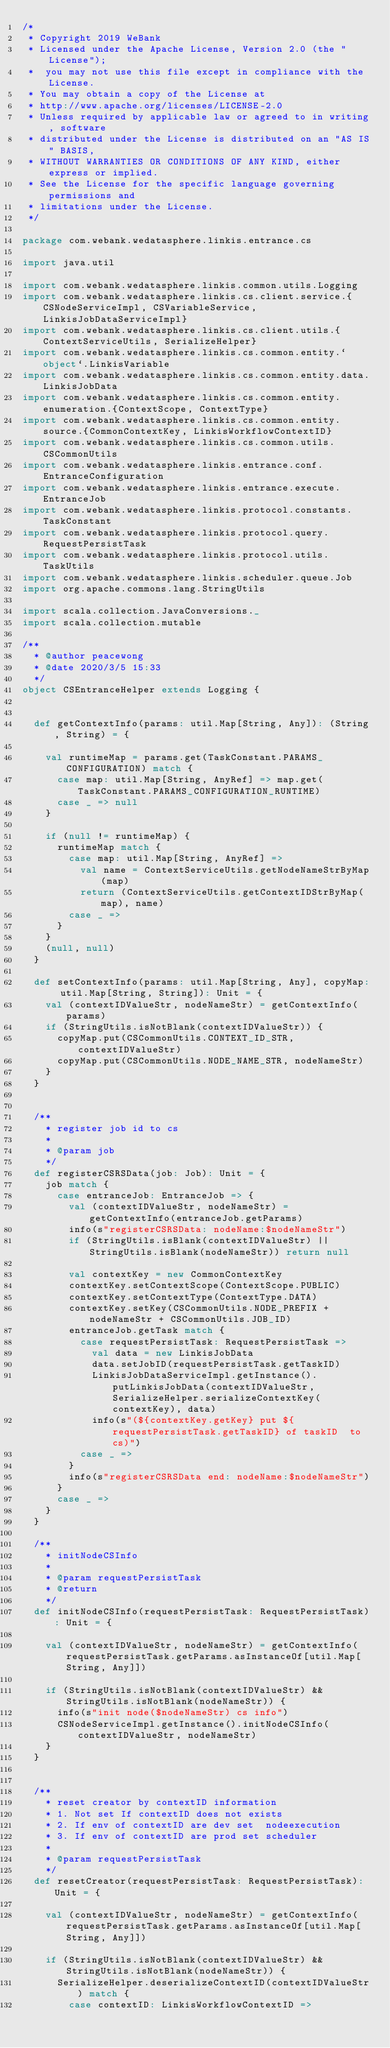Convert code to text. <code><loc_0><loc_0><loc_500><loc_500><_Scala_>/*
 * Copyright 2019 WeBank
 * Licensed under the Apache License, Version 2.0 (the "License");
 *  you may not use this file except in compliance with the License.
 * You may obtain a copy of the License at
 * http://www.apache.org/licenses/LICENSE-2.0
 * Unless required by applicable law or agreed to in writing, software
 * distributed under the License is distributed on an "AS IS" BASIS,
 * WITHOUT WARRANTIES OR CONDITIONS OF ANY KIND, either express or implied.
 * See the License for the specific language governing permissions and
 * limitations under the License.
 */

package com.webank.wedatasphere.linkis.entrance.cs

import java.util

import com.webank.wedatasphere.linkis.common.utils.Logging
import com.webank.wedatasphere.linkis.cs.client.service.{CSNodeServiceImpl, CSVariableService, LinkisJobDataServiceImpl}
import com.webank.wedatasphere.linkis.cs.client.utils.{ContextServiceUtils, SerializeHelper}
import com.webank.wedatasphere.linkis.cs.common.entity.`object`.LinkisVariable
import com.webank.wedatasphere.linkis.cs.common.entity.data.LinkisJobData
import com.webank.wedatasphere.linkis.cs.common.entity.enumeration.{ContextScope, ContextType}
import com.webank.wedatasphere.linkis.cs.common.entity.source.{CommonContextKey, LinkisWorkflowContextID}
import com.webank.wedatasphere.linkis.cs.common.utils.CSCommonUtils
import com.webank.wedatasphere.linkis.entrance.conf.EntranceConfiguration
import com.webank.wedatasphere.linkis.entrance.execute.EntranceJob
import com.webank.wedatasphere.linkis.protocol.constants.TaskConstant
import com.webank.wedatasphere.linkis.protocol.query.RequestPersistTask
import com.webank.wedatasphere.linkis.protocol.utils.TaskUtils
import com.webank.wedatasphere.linkis.scheduler.queue.Job
import org.apache.commons.lang.StringUtils

import scala.collection.JavaConversions._
import scala.collection.mutable

/**
  * @author peacewong
  * @date 2020/3/5 15:33
  */
object CSEntranceHelper extends Logging {


  def getContextInfo(params: util.Map[String, Any]): (String, String) = {

    val runtimeMap = params.get(TaskConstant.PARAMS_CONFIGURATION) match {
      case map: util.Map[String, AnyRef] => map.get(TaskConstant.PARAMS_CONFIGURATION_RUNTIME)
      case _ => null
    }

    if (null != runtimeMap) {
      runtimeMap match {
        case map: util.Map[String, AnyRef] =>
          val name = ContextServiceUtils.getNodeNameStrByMap(map)
          return (ContextServiceUtils.getContextIDStrByMap(map), name)
        case _ =>
      }
    }
    (null, null)
  }

  def setContextInfo(params: util.Map[String, Any], copyMap: util.Map[String, String]): Unit = {
    val (contextIDValueStr, nodeNameStr) = getContextInfo(params)
    if (StringUtils.isNotBlank(contextIDValueStr)) {
      copyMap.put(CSCommonUtils.CONTEXT_ID_STR, contextIDValueStr)
      copyMap.put(CSCommonUtils.NODE_NAME_STR, nodeNameStr)
    }
  }


  /**
    * register job id to cs
    *
    * @param job
    */
  def registerCSRSData(job: Job): Unit = {
    job match {
      case entranceJob: EntranceJob => {
        val (contextIDValueStr, nodeNameStr) = getContextInfo(entranceJob.getParams)
        info(s"registerCSRSData: nodeName:$nodeNameStr")
        if (StringUtils.isBlank(contextIDValueStr) || StringUtils.isBlank(nodeNameStr)) return null

        val contextKey = new CommonContextKey
        contextKey.setContextScope(ContextScope.PUBLIC)
        contextKey.setContextType(ContextType.DATA)
        contextKey.setKey(CSCommonUtils.NODE_PREFIX + nodeNameStr + CSCommonUtils.JOB_ID)
        entranceJob.getTask match {
          case requestPersistTask: RequestPersistTask =>
            val data = new LinkisJobData
            data.setJobID(requestPersistTask.getTaskID)
            LinkisJobDataServiceImpl.getInstance().putLinkisJobData(contextIDValueStr, SerializeHelper.serializeContextKey(contextKey), data)
            info(s"(${contextKey.getKey} put ${requestPersistTask.getTaskID} of taskID  to cs)")
          case _ =>
        }
        info(s"registerCSRSData end: nodeName:$nodeNameStr")
      }
      case _ =>
    }
  }

  /**
    * initNodeCSInfo
    *
    * @param requestPersistTask
    * @return
    */
  def initNodeCSInfo(requestPersistTask: RequestPersistTask): Unit = {

    val (contextIDValueStr, nodeNameStr) = getContextInfo(requestPersistTask.getParams.asInstanceOf[util.Map[String, Any]])

    if (StringUtils.isNotBlank(contextIDValueStr) && StringUtils.isNotBlank(nodeNameStr)) {
      info(s"init node($nodeNameStr) cs info")
      CSNodeServiceImpl.getInstance().initNodeCSInfo(contextIDValueStr, nodeNameStr)
    }
  }


  /**
    * reset creator by contextID information
    * 1. Not set If contextID does not exists
    * 2. If env of contextID are dev set  nodeexecution
    * 3. If env of contextID are prod set scheduler
    *
    * @param requestPersistTask
    */
  def resetCreator(requestPersistTask: RequestPersistTask): Unit = {

    val (contextIDValueStr, nodeNameStr) = getContextInfo(requestPersistTask.getParams.asInstanceOf[util.Map[String, Any]])

    if (StringUtils.isNotBlank(contextIDValueStr) && StringUtils.isNotBlank(nodeNameStr)) {
      SerializeHelper.deserializeContextID(contextIDValueStr) match {
        case contextID: LinkisWorkflowContextID =></code> 